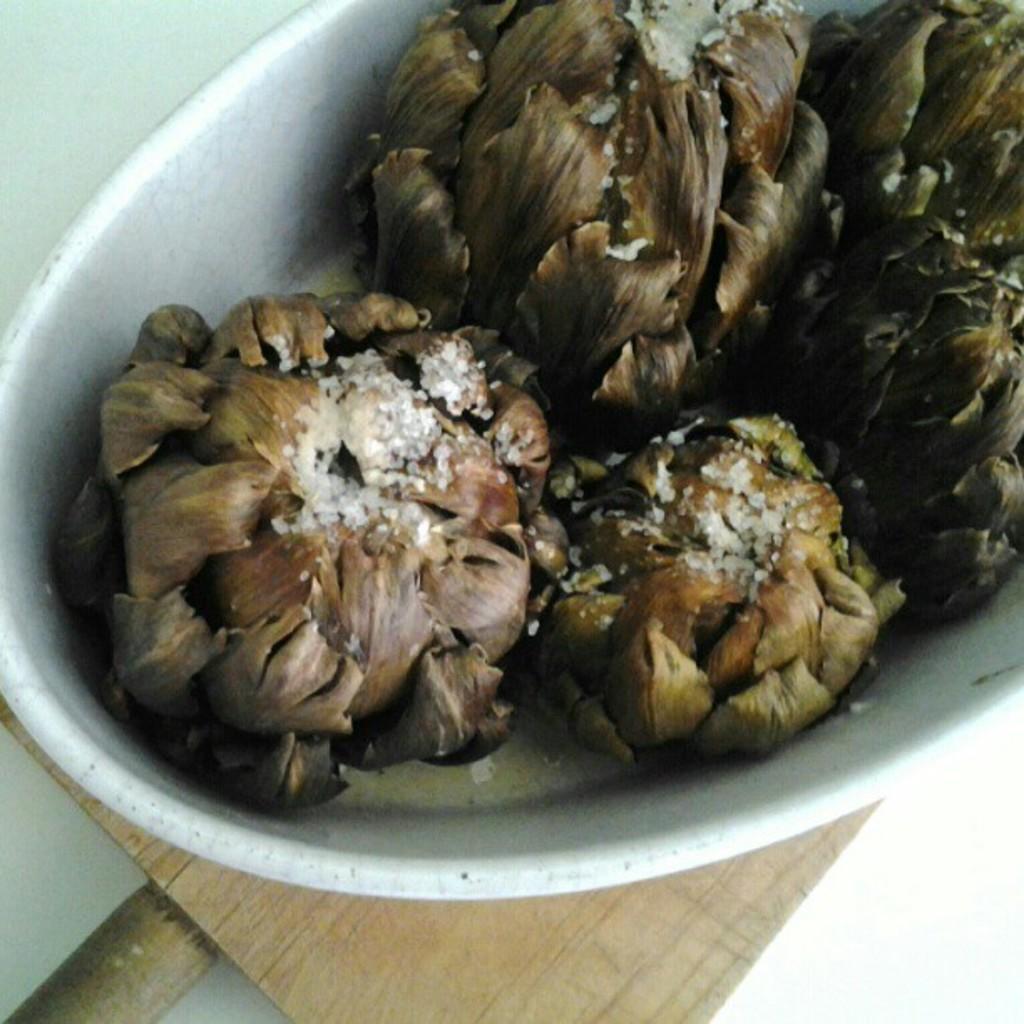Could you give a brief overview of what you see in this image? In this picture there are some fruits placed in the white color basket which is placed on the table. The table is in brown color. 